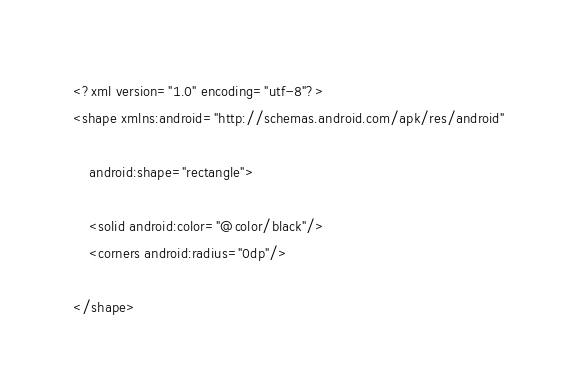<code> <loc_0><loc_0><loc_500><loc_500><_XML_><?xml version="1.0" encoding="utf-8"?>
<shape xmlns:android="http://schemas.android.com/apk/res/android"

    android:shape="rectangle">

    <solid android:color="@color/black"/>
    <corners android:radius="0dp"/>

</shape></code> 